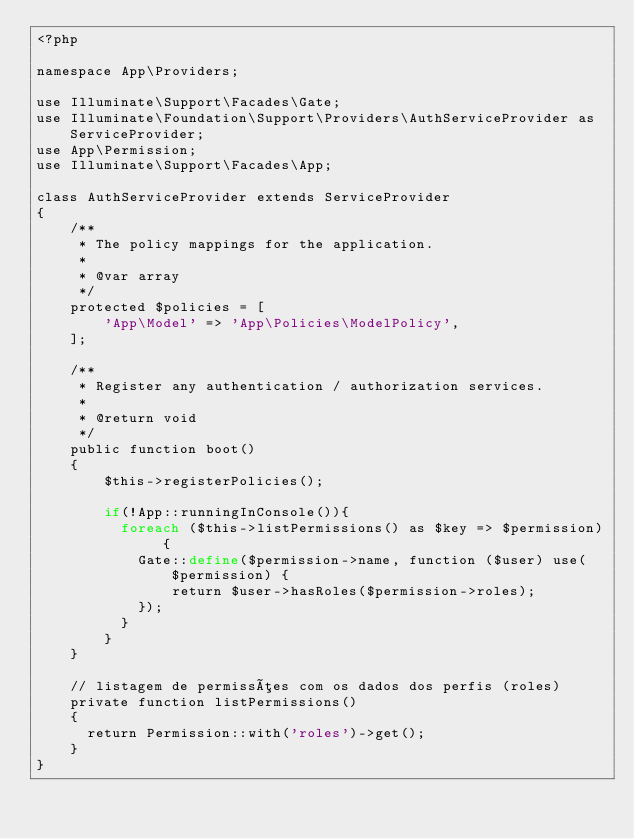<code> <loc_0><loc_0><loc_500><loc_500><_PHP_><?php

namespace App\Providers;

use Illuminate\Support\Facades\Gate;
use Illuminate\Foundation\Support\Providers\AuthServiceProvider as ServiceProvider;
use App\Permission;
use Illuminate\Support\Facades\App;

class AuthServiceProvider extends ServiceProvider
{
    /**
     * The policy mappings for the application.
     *
     * @var array
     */
    protected $policies = [
        'App\Model' => 'App\Policies\ModelPolicy',
    ];

    /**
     * Register any authentication / authorization services.
     *
     * @return void
     */
    public function boot()
    {
        $this->registerPolicies();

        if(!App::runningInConsole()){
          foreach ($this->listPermissions() as $key => $permission) {
            Gate::define($permission->name, function ($user) use($permission) {
                return $user->hasRoles($permission->roles);
            });
          }
        }
    }

    // listagem de permissões com os dados dos perfis (roles)
    private function listPermissions()
    {
      return Permission::with('roles')->get();
    }
}
</code> 